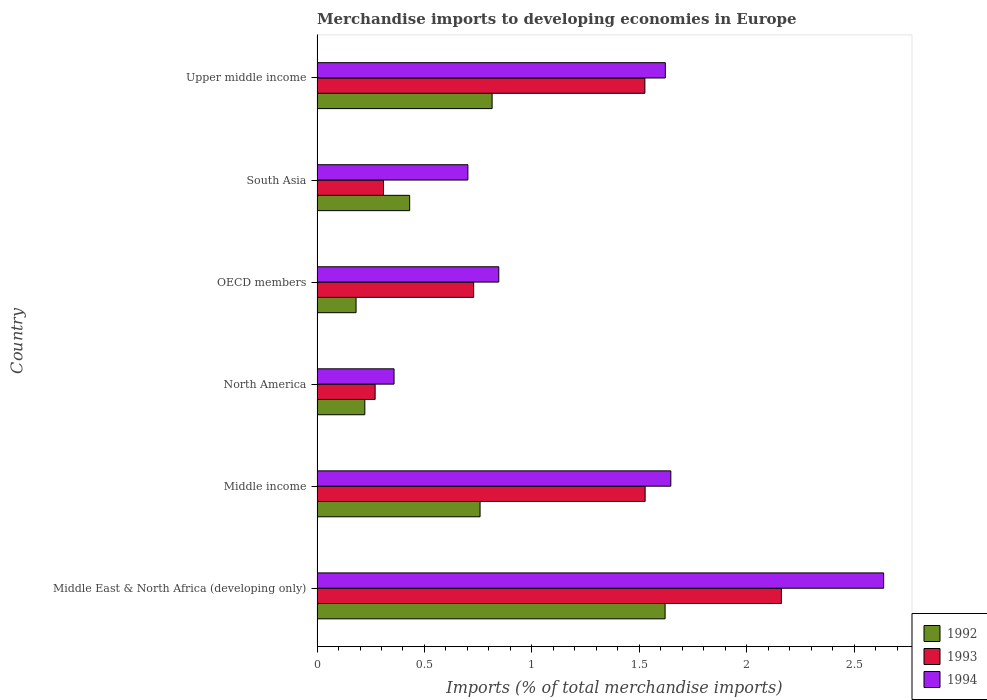How many different coloured bars are there?
Your answer should be compact. 3. How many groups of bars are there?
Offer a very short reply. 6. Are the number of bars per tick equal to the number of legend labels?
Keep it short and to the point. Yes. Are the number of bars on each tick of the Y-axis equal?
Your response must be concise. Yes. How many bars are there on the 6th tick from the top?
Ensure brevity in your answer.  3. How many bars are there on the 5th tick from the bottom?
Your response must be concise. 3. What is the label of the 3rd group of bars from the top?
Provide a succinct answer. OECD members. What is the percentage total merchandise imports in 1992 in OECD members?
Offer a terse response. 0.18. Across all countries, what is the maximum percentage total merchandise imports in 1992?
Your response must be concise. 1.62. Across all countries, what is the minimum percentage total merchandise imports in 1993?
Your answer should be compact. 0.27. In which country was the percentage total merchandise imports in 1993 maximum?
Your answer should be very brief. Middle East & North Africa (developing only). In which country was the percentage total merchandise imports in 1993 minimum?
Give a very brief answer. North America. What is the total percentage total merchandise imports in 1992 in the graph?
Your response must be concise. 4.03. What is the difference between the percentage total merchandise imports in 1994 in Middle East & North Africa (developing only) and that in South Asia?
Ensure brevity in your answer.  1.94. What is the difference between the percentage total merchandise imports in 1994 in Middle East & North Africa (developing only) and the percentage total merchandise imports in 1993 in OECD members?
Make the answer very short. 1.91. What is the average percentage total merchandise imports in 1992 per country?
Provide a short and direct response. 0.67. What is the difference between the percentage total merchandise imports in 1994 and percentage total merchandise imports in 1993 in Middle income?
Ensure brevity in your answer.  0.12. What is the ratio of the percentage total merchandise imports in 1993 in Middle East & North Africa (developing only) to that in Middle income?
Your answer should be compact. 1.42. Is the difference between the percentage total merchandise imports in 1994 in Middle income and Upper middle income greater than the difference between the percentage total merchandise imports in 1993 in Middle income and Upper middle income?
Your answer should be compact. Yes. What is the difference between the highest and the second highest percentage total merchandise imports in 1994?
Provide a succinct answer. 0.99. What is the difference between the highest and the lowest percentage total merchandise imports in 1993?
Your answer should be compact. 1.89. In how many countries, is the percentage total merchandise imports in 1994 greater than the average percentage total merchandise imports in 1994 taken over all countries?
Offer a terse response. 3. Is the sum of the percentage total merchandise imports in 1992 in Middle East & North Africa (developing only) and OECD members greater than the maximum percentage total merchandise imports in 1994 across all countries?
Keep it short and to the point. No. What does the 2nd bar from the bottom in Middle East & North Africa (developing only) represents?
Provide a short and direct response. 1993. How many bars are there?
Ensure brevity in your answer.  18. Are all the bars in the graph horizontal?
Make the answer very short. Yes. What is the difference between two consecutive major ticks on the X-axis?
Your response must be concise. 0.5. How many legend labels are there?
Keep it short and to the point. 3. What is the title of the graph?
Offer a very short reply. Merchandise imports to developing economies in Europe. What is the label or title of the X-axis?
Your response must be concise. Imports (% of total merchandise imports). What is the label or title of the Y-axis?
Your answer should be very brief. Country. What is the Imports (% of total merchandise imports) in 1992 in Middle East & North Africa (developing only)?
Your answer should be compact. 1.62. What is the Imports (% of total merchandise imports) of 1993 in Middle East & North Africa (developing only)?
Ensure brevity in your answer.  2.16. What is the Imports (% of total merchandise imports) of 1994 in Middle East & North Africa (developing only)?
Your answer should be very brief. 2.64. What is the Imports (% of total merchandise imports) in 1992 in Middle income?
Offer a very short reply. 0.76. What is the Imports (% of total merchandise imports) in 1993 in Middle income?
Provide a succinct answer. 1.53. What is the Imports (% of total merchandise imports) of 1994 in Middle income?
Make the answer very short. 1.65. What is the Imports (% of total merchandise imports) in 1992 in North America?
Offer a very short reply. 0.22. What is the Imports (% of total merchandise imports) of 1993 in North America?
Your answer should be compact. 0.27. What is the Imports (% of total merchandise imports) of 1994 in North America?
Make the answer very short. 0.36. What is the Imports (% of total merchandise imports) of 1992 in OECD members?
Offer a terse response. 0.18. What is the Imports (% of total merchandise imports) of 1993 in OECD members?
Provide a short and direct response. 0.73. What is the Imports (% of total merchandise imports) of 1994 in OECD members?
Make the answer very short. 0.85. What is the Imports (% of total merchandise imports) of 1992 in South Asia?
Your response must be concise. 0.43. What is the Imports (% of total merchandise imports) of 1993 in South Asia?
Keep it short and to the point. 0.31. What is the Imports (% of total merchandise imports) in 1994 in South Asia?
Give a very brief answer. 0.7. What is the Imports (% of total merchandise imports) in 1992 in Upper middle income?
Ensure brevity in your answer.  0.81. What is the Imports (% of total merchandise imports) in 1993 in Upper middle income?
Provide a succinct answer. 1.53. What is the Imports (% of total merchandise imports) of 1994 in Upper middle income?
Ensure brevity in your answer.  1.62. Across all countries, what is the maximum Imports (% of total merchandise imports) in 1992?
Provide a succinct answer. 1.62. Across all countries, what is the maximum Imports (% of total merchandise imports) in 1993?
Your answer should be compact. 2.16. Across all countries, what is the maximum Imports (% of total merchandise imports) in 1994?
Keep it short and to the point. 2.64. Across all countries, what is the minimum Imports (% of total merchandise imports) in 1992?
Your response must be concise. 0.18. Across all countries, what is the minimum Imports (% of total merchandise imports) in 1993?
Your response must be concise. 0.27. Across all countries, what is the minimum Imports (% of total merchandise imports) of 1994?
Offer a very short reply. 0.36. What is the total Imports (% of total merchandise imports) of 1992 in the graph?
Keep it short and to the point. 4.03. What is the total Imports (% of total merchandise imports) in 1993 in the graph?
Your response must be concise. 6.52. What is the total Imports (% of total merchandise imports) in 1994 in the graph?
Give a very brief answer. 7.81. What is the difference between the Imports (% of total merchandise imports) of 1992 in Middle East & North Africa (developing only) and that in Middle income?
Provide a succinct answer. 0.86. What is the difference between the Imports (% of total merchandise imports) of 1993 in Middle East & North Africa (developing only) and that in Middle income?
Provide a succinct answer. 0.63. What is the difference between the Imports (% of total merchandise imports) of 1992 in Middle East & North Africa (developing only) and that in North America?
Provide a short and direct response. 1.4. What is the difference between the Imports (% of total merchandise imports) in 1993 in Middle East & North Africa (developing only) and that in North America?
Give a very brief answer. 1.89. What is the difference between the Imports (% of total merchandise imports) of 1994 in Middle East & North Africa (developing only) and that in North America?
Provide a succinct answer. 2.28. What is the difference between the Imports (% of total merchandise imports) of 1992 in Middle East & North Africa (developing only) and that in OECD members?
Keep it short and to the point. 1.44. What is the difference between the Imports (% of total merchandise imports) of 1993 in Middle East & North Africa (developing only) and that in OECD members?
Offer a terse response. 1.43. What is the difference between the Imports (% of total merchandise imports) in 1994 in Middle East & North Africa (developing only) and that in OECD members?
Keep it short and to the point. 1.79. What is the difference between the Imports (% of total merchandise imports) in 1992 in Middle East & North Africa (developing only) and that in South Asia?
Provide a succinct answer. 1.19. What is the difference between the Imports (% of total merchandise imports) of 1993 in Middle East & North Africa (developing only) and that in South Asia?
Offer a terse response. 1.85. What is the difference between the Imports (% of total merchandise imports) of 1994 in Middle East & North Africa (developing only) and that in South Asia?
Your answer should be compact. 1.94. What is the difference between the Imports (% of total merchandise imports) in 1992 in Middle East & North Africa (developing only) and that in Upper middle income?
Provide a short and direct response. 0.81. What is the difference between the Imports (% of total merchandise imports) in 1993 in Middle East & North Africa (developing only) and that in Upper middle income?
Make the answer very short. 0.64. What is the difference between the Imports (% of total merchandise imports) of 1994 in Middle East & North Africa (developing only) and that in Upper middle income?
Make the answer very short. 1.02. What is the difference between the Imports (% of total merchandise imports) in 1992 in Middle income and that in North America?
Ensure brevity in your answer.  0.54. What is the difference between the Imports (% of total merchandise imports) in 1993 in Middle income and that in North America?
Provide a short and direct response. 1.26. What is the difference between the Imports (% of total merchandise imports) in 1994 in Middle income and that in North America?
Keep it short and to the point. 1.29. What is the difference between the Imports (% of total merchandise imports) of 1992 in Middle income and that in OECD members?
Provide a succinct answer. 0.58. What is the difference between the Imports (% of total merchandise imports) in 1993 in Middle income and that in OECD members?
Ensure brevity in your answer.  0.8. What is the difference between the Imports (% of total merchandise imports) in 1994 in Middle income and that in OECD members?
Your response must be concise. 0.8. What is the difference between the Imports (% of total merchandise imports) in 1992 in Middle income and that in South Asia?
Your response must be concise. 0.33. What is the difference between the Imports (% of total merchandise imports) of 1993 in Middle income and that in South Asia?
Ensure brevity in your answer.  1.22. What is the difference between the Imports (% of total merchandise imports) of 1994 in Middle income and that in South Asia?
Your answer should be compact. 0.94. What is the difference between the Imports (% of total merchandise imports) of 1992 in Middle income and that in Upper middle income?
Provide a short and direct response. -0.06. What is the difference between the Imports (% of total merchandise imports) in 1993 in Middle income and that in Upper middle income?
Keep it short and to the point. 0. What is the difference between the Imports (% of total merchandise imports) in 1994 in Middle income and that in Upper middle income?
Offer a terse response. 0.03. What is the difference between the Imports (% of total merchandise imports) of 1992 in North America and that in OECD members?
Your response must be concise. 0.04. What is the difference between the Imports (% of total merchandise imports) in 1993 in North America and that in OECD members?
Offer a terse response. -0.46. What is the difference between the Imports (% of total merchandise imports) of 1994 in North America and that in OECD members?
Make the answer very short. -0.49. What is the difference between the Imports (% of total merchandise imports) in 1992 in North America and that in South Asia?
Your answer should be compact. -0.21. What is the difference between the Imports (% of total merchandise imports) of 1993 in North America and that in South Asia?
Give a very brief answer. -0.04. What is the difference between the Imports (% of total merchandise imports) in 1994 in North America and that in South Asia?
Make the answer very short. -0.34. What is the difference between the Imports (% of total merchandise imports) of 1992 in North America and that in Upper middle income?
Provide a succinct answer. -0.59. What is the difference between the Imports (% of total merchandise imports) in 1993 in North America and that in Upper middle income?
Offer a terse response. -1.26. What is the difference between the Imports (% of total merchandise imports) of 1994 in North America and that in Upper middle income?
Give a very brief answer. -1.26. What is the difference between the Imports (% of total merchandise imports) of 1992 in OECD members and that in South Asia?
Your response must be concise. -0.25. What is the difference between the Imports (% of total merchandise imports) of 1993 in OECD members and that in South Asia?
Your answer should be compact. 0.42. What is the difference between the Imports (% of total merchandise imports) of 1994 in OECD members and that in South Asia?
Your answer should be compact. 0.14. What is the difference between the Imports (% of total merchandise imports) in 1992 in OECD members and that in Upper middle income?
Your answer should be compact. -0.63. What is the difference between the Imports (% of total merchandise imports) in 1993 in OECD members and that in Upper middle income?
Your answer should be compact. -0.8. What is the difference between the Imports (% of total merchandise imports) of 1994 in OECD members and that in Upper middle income?
Your answer should be compact. -0.78. What is the difference between the Imports (% of total merchandise imports) in 1992 in South Asia and that in Upper middle income?
Provide a succinct answer. -0.38. What is the difference between the Imports (% of total merchandise imports) in 1993 in South Asia and that in Upper middle income?
Provide a short and direct response. -1.22. What is the difference between the Imports (% of total merchandise imports) in 1994 in South Asia and that in Upper middle income?
Ensure brevity in your answer.  -0.92. What is the difference between the Imports (% of total merchandise imports) in 1992 in Middle East & North Africa (developing only) and the Imports (% of total merchandise imports) in 1993 in Middle income?
Make the answer very short. 0.09. What is the difference between the Imports (% of total merchandise imports) in 1992 in Middle East & North Africa (developing only) and the Imports (% of total merchandise imports) in 1994 in Middle income?
Ensure brevity in your answer.  -0.03. What is the difference between the Imports (% of total merchandise imports) in 1993 in Middle East & North Africa (developing only) and the Imports (% of total merchandise imports) in 1994 in Middle income?
Provide a short and direct response. 0.51. What is the difference between the Imports (% of total merchandise imports) of 1992 in Middle East & North Africa (developing only) and the Imports (% of total merchandise imports) of 1993 in North America?
Offer a very short reply. 1.35. What is the difference between the Imports (% of total merchandise imports) in 1992 in Middle East & North Africa (developing only) and the Imports (% of total merchandise imports) in 1994 in North America?
Provide a succinct answer. 1.26. What is the difference between the Imports (% of total merchandise imports) in 1993 in Middle East & North Africa (developing only) and the Imports (% of total merchandise imports) in 1994 in North America?
Your response must be concise. 1.8. What is the difference between the Imports (% of total merchandise imports) of 1992 in Middle East & North Africa (developing only) and the Imports (% of total merchandise imports) of 1993 in OECD members?
Provide a succinct answer. 0.89. What is the difference between the Imports (% of total merchandise imports) in 1992 in Middle East & North Africa (developing only) and the Imports (% of total merchandise imports) in 1994 in OECD members?
Provide a short and direct response. 0.77. What is the difference between the Imports (% of total merchandise imports) in 1993 in Middle East & North Africa (developing only) and the Imports (% of total merchandise imports) in 1994 in OECD members?
Offer a very short reply. 1.32. What is the difference between the Imports (% of total merchandise imports) of 1992 in Middle East & North Africa (developing only) and the Imports (% of total merchandise imports) of 1993 in South Asia?
Ensure brevity in your answer.  1.31. What is the difference between the Imports (% of total merchandise imports) in 1992 in Middle East & North Africa (developing only) and the Imports (% of total merchandise imports) in 1994 in South Asia?
Keep it short and to the point. 0.92. What is the difference between the Imports (% of total merchandise imports) of 1993 in Middle East & North Africa (developing only) and the Imports (% of total merchandise imports) of 1994 in South Asia?
Ensure brevity in your answer.  1.46. What is the difference between the Imports (% of total merchandise imports) in 1992 in Middle East & North Africa (developing only) and the Imports (% of total merchandise imports) in 1993 in Upper middle income?
Your answer should be very brief. 0.09. What is the difference between the Imports (% of total merchandise imports) of 1992 in Middle East & North Africa (developing only) and the Imports (% of total merchandise imports) of 1994 in Upper middle income?
Ensure brevity in your answer.  -0. What is the difference between the Imports (% of total merchandise imports) in 1993 in Middle East & North Africa (developing only) and the Imports (% of total merchandise imports) in 1994 in Upper middle income?
Your answer should be compact. 0.54. What is the difference between the Imports (% of total merchandise imports) of 1992 in Middle income and the Imports (% of total merchandise imports) of 1993 in North America?
Ensure brevity in your answer.  0.49. What is the difference between the Imports (% of total merchandise imports) of 1992 in Middle income and the Imports (% of total merchandise imports) of 1994 in North America?
Offer a terse response. 0.4. What is the difference between the Imports (% of total merchandise imports) of 1993 in Middle income and the Imports (% of total merchandise imports) of 1994 in North America?
Provide a succinct answer. 1.17. What is the difference between the Imports (% of total merchandise imports) in 1992 in Middle income and the Imports (% of total merchandise imports) in 1993 in OECD members?
Your answer should be compact. 0.03. What is the difference between the Imports (% of total merchandise imports) in 1992 in Middle income and the Imports (% of total merchandise imports) in 1994 in OECD members?
Ensure brevity in your answer.  -0.09. What is the difference between the Imports (% of total merchandise imports) of 1993 in Middle income and the Imports (% of total merchandise imports) of 1994 in OECD members?
Your answer should be very brief. 0.68. What is the difference between the Imports (% of total merchandise imports) in 1992 in Middle income and the Imports (% of total merchandise imports) in 1993 in South Asia?
Your answer should be compact. 0.45. What is the difference between the Imports (% of total merchandise imports) in 1992 in Middle income and the Imports (% of total merchandise imports) in 1994 in South Asia?
Your answer should be compact. 0.06. What is the difference between the Imports (% of total merchandise imports) of 1993 in Middle income and the Imports (% of total merchandise imports) of 1994 in South Asia?
Make the answer very short. 0.82. What is the difference between the Imports (% of total merchandise imports) in 1992 in Middle income and the Imports (% of total merchandise imports) in 1993 in Upper middle income?
Offer a very short reply. -0.77. What is the difference between the Imports (% of total merchandise imports) of 1992 in Middle income and the Imports (% of total merchandise imports) of 1994 in Upper middle income?
Provide a succinct answer. -0.86. What is the difference between the Imports (% of total merchandise imports) of 1993 in Middle income and the Imports (% of total merchandise imports) of 1994 in Upper middle income?
Ensure brevity in your answer.  -0.09. What is the difference between the Imports (% of total merchandise imports) in 1992 in North America and the Imports (% of total merchandise imports) in 1993 in OECD members?
Your answer should be compact. -0.51. What is the difference between the Imports (% of total merchandise imports) of 1992 in North America and the Imports (% of total merchandise imports) of 1994 in OECD members?
Keep it short and to the point. -0.62. What is the difference between the Imports (% of total merchandise imports) in 1993 in North America and the Imports (% of total merchandise imports) in 1994 in OECD members?
Offer a terse response. -0.58. What is the difference between the Imports (% of total merchandise imports) in 1992 in North America and the Imports (% of total merchandise imports) in 1993 in South Asia?
Give a very brief answer. -0.09. What is the difference between the Imports (% of total merchandise imports) in 1992 in North America and the Imports (% of total merchandise imports) in 1994 in South Asia?
Provide a succinct answer. -0.48. What is the difference between the Imports (% of total merchandise imports) in 1993 in North America and the Imports (% of total merchandise imports) in 1994 in South Asia?
Provide a succinct answer. -0.43. What is the difference between the Imports (% of total merchandise imports) in 1992 in North America and the Imports (% of total merchandise imports) in 1993 in Upper middle income?
Keep it short and to the point. -1.3. What is the difference between the Imports (% of total merchandise imports) of 1992 in North America and the Imports (% of total merchandise imports) of 1994 in Upper middle income?
Offer a very short reply. -1.4. What is the difference between the Imports (% of total merchandise imports) of 1993 in North America and the Imports (% of total merchandise imports) of 1994 in Upper middle income?
Your answer should be compact. -1.35. What is the difference between the Imports (% of total merchandise imports) of 1992 in OECD members and the Imports (% of total merchandise imports) of 1993 in South Asia?
Your answer should be very brief. -0.13. What is the difference between the Imports (% of total merchandise imports) of 1992 in OECD members and the Imports (% of total merchandise imports) of 1994 in South Asia?
Provide a short and direct response. -0.52. What is the difference between the Imports (% of total merchandise imports) in 1993 in OECD members and the Imports (% of total merchandise imports) in 1994 in South Asia?
Provide a succinct answer. 0.03. What is the difference between the Imports (% of total merchandise imports) of 1992 in OECD members and the Imports (% of total merchandise imports) of 1993 in Upper middle income?
Your answer should be very brief. -1.34. What is the difference between the Imports (% of total merchandise imports) in 1992 in OECD members and the Imports (% of total merchandise imports) in 1994 in Upper middle income?
Provide a short and direct response. -1.44. What is the difference between the Imports (% of total merchandise imports) of 1993 in OECD members and the Imports (% of total merchandise imports) of 1994 in Upper middle income?
Your answer should be compact. -0.89. What is the difference between the Imports (% of total merchandise imports) of 1992 in South Asia and the Imports (% of total merchandise imports) of 1993 in Upper middle income?
Your answer should be very brief. -1.09. What is the difference between the Imports (% of total merchandise imports) in 1992 in South Asia and the Imports (% of total merchandise imports) in 1994 in Upper middle income?
Ensure brevity in your answer.  -1.19. What is the difference between the Imports (% of total merchandise imports) of 1993 in South Asia and the Imports (% of total merchandise imports) of 1994 in Upper middle income?
Ensure brevity in your answer.  -1.31. What is the average Imports (% of total merchandise imports) in 1992 per country?
Your answer should be compact. 0.67. What is the average Imports (% of total merchandise imports) in 1993 per country?
Ensure brevity in your answer.  1.09. What is the average Imports (% of total merchandise imports) in 1994 per country?
Your answer should be very brief. 1.3. What is the difference between the Imports (% of total merchandise imports) of 1992 and Imports (% of total merchandise imports) of 1993 in Middle East & North Africa (developing only)?
Offer a terse response. -0.54. What is the difference between the Imports (% of total merchandise imports) in 1992 and Imports (% of total merchandise imports) in 1994 in Middle East & North Africa (developing only)?
Keep it short and to the point. -1.02. What is the difference between the Imports (% of total merchandise imports) of 1993 and Imports (% of total merchandise imports) of 1994 in Middle East & North Africa (developing only)?
Your answer should be very brief. -0.48. What is the difference between the Imports (% of total merchandise imports) in 1992 and Imports (% of total merchandise imports) in 1993 in Middle income?
Provide a succinct answer. -0.77. What is the difference between the Imports (% of total merchandise imports) of 1992 and Imports (% of total merchandise imports) of 1994 in Middle income?
Provide a short and direct response. -0.89. What is the difference between the Imports (% of total merchandise imports) in 1993 and Imports (% of total merchandise imports) in 1994 in Middle income?
Provide a short and direct response. -0.12. What is the difference between the Imports (% of total merchandise imports) in 1992 and Imports (% of total merchandise imports) in 1993 in North America?
Your response must be concise. -0.05. What is the difference between the Imports (% of total merchandise imports) in 1992 and Imports (% of total merchandise imports) in 1994 in North America?
Provide a succinct answer. -0.14. What is the difference between the Imports (% of total merchandise imports) in 1993 and Imports (% of total merchandise imports) in 1994 in North America?
Keep it short and to the point. -0.09. What is the difference between the Imports (% of total merchandise imports) of 1992 and Imports (% of total merchandise imports) of 1993 in OECD members?
Make the answer very short. -0.55. What is the difference between the Imports (% of total merchandise imports) in 1992 and Imports (% of total merchandise imports) in 1994 in OECD members?
Ensure brevity in your answer.  -0.66. What is the difference between the Imports (% of total merchandise imports) in 1993 and Imports (% of total merchandise imports) in 1994 in OECD members?
Your answer should be very brief. -0.12. What is the difference between the Imports (% of total merchandise imports) in 1992 and Imports (% of total merchandise imports) in 1993 in South Asia?
Your response must be concise. 0.12. What is the difference between the Imports (% of total merchandise imports) of 1992 and Imports (% of total merchandise imports) of 1994 in South Asia?
Ensure brevity in your answer.  -0.27. What is the difference between the Imports (% of total merchandise imports) in 1993 and Imports (% of total merchandise imports) in 1994 in South Asia?
Make the answer very short. -0.39. What is the difference between the Imports (% of total merchandise imports) of 1992 and Imports (% of total merchandise imports) of 1993 in Upper middle income?
Your answer should be very brief. -0.71. What is the difference between the Imports (% of total merchandise imports) in 1992 and Imports (% of total merchandise imports) in 1994 in Upper middle income?
Provide a succinct answer. -0.81. What is the difference between the Imports (% of total merchandise imports) of 1993 and Imports (% of total merchandise imports) of 1994 in Upper middle income?
Ensure brevity in your answer.  -0.1. What is the ratio of the Imports (% of total merchandise imports) in 1992 in Middle East & North Africa (developing only) to that in Middle income?
Ensure brevity in your answer.  2.14. What is the ratio of the Imports (% of total merchandise imports) in 1993 in Middle East & North Africa (developing only) to that in Middle income?
Your answer should be very brief. 1.42. What is the ratio of the Imports (% of total merchandise imports) of 1994 in Middle East & North Africa (developing only) to that in Middle income?
Your answer should be very brief. 1.6. What is the ratio of the Imports (% of total merchandise imports) in 1992 in Middle East & North Africa (developing only) to that in North America?
Keep it short and to the point. 7.28. What is the ratio of the Imports (% of total merchandise imports) of 1993 in Middle East & North Africa (developing only) to that in North America?
Your response must be concise. 8. What is the ratio of the Imports (% of total merchandise imports) in 1994 in Middle East & North Africa (developing only) to that in North America?
Offer a very short reply. 7.36. What is the ratio of the Imports (% of total merchandise imports) in 1992 in Middle East & North Africa (developing only) to that in OECD members?
Keep it short and to the point. 8.92. What is the ratio of the Imports (% of total merchandise imports) in 1993 in Middle East & North Africa (developing only) to that in OECD members?
Keep it short and to the point. 2.97. What is the ratio of the Imports (% of total merchandise imports) in 1994 in Middle East & North Africa (developing only) to that in OECD members?
Make the answer very short. 3.12. What is the ratio of the Imports (% of total merchandise imports) of 1992 in Middle East & North Africa (developing only) to that in South Asia?
Your response must be concise. 3.76. What is the ratio of the Imports (% of total merchandise imports) of 1993 in Middle East & North Africa (developing only) to that in South Asia?
Provide a succinct answer. 6.99. What is the ratio of the Imports (% of total merchandise imports) of 1994 in Middle East & North Africa (developing only) to that in South Asia?
Your answer should be compact. 3.76. What is the ratio of the Imports (% of total merchandise imports) in 1992 in Middle East & North Africa (developing only) to that in Upper middle income?
Give a very brief answer. 1.99. What is the ratio of the Imports (% of total merchandise imports) in 1993 in Middle East & North Africa (developing only) to that in Upper middle income?
Give a very brief answer. 1.42. What is the ratio of the Imports (% of total merchandise imports) in 1994 in Middle East & North Africa (developing only) to that in Upper middle income?
Keep it short and to the point. 1.63. What is the ratio of the Imports (% of total merchandise imports) of 1992 in Middle income to that in North America?
Offer a very short reply. 3.41. What is the ratio of the Imports (% of total merchandise imports) of 1993 in Middle income to that in North America?
Offer a terse response. 5.65. What is the ratio of the Imports (% of total merchandise imports) in 1994 in Middle income to that in North America?
Your response must be concise. 4.6. What is the ratio of the Imports (% of total merchandise imports) in 1992 in Middle income to that in OECD members?
Your answer should be very brief. 4.18. What is the ratio of the Imports (% of total merchandise imports) in 1993 in Middle income to that in OECD members?
Your answer should be compact. 2.1. What is the ratio of the Imports (% of total merchandise imports) in 1994 in Middle income to that in OECD members?
Ensure brevity in your answer.  1.95. What is the ratio of the Imports (% of total merchandise imports) in 1992 in Middle income to that in South Asia?
Your answer should be compact. 1.76. What is the ratio of the Imports (% of total merchandise imports) of 1993 in Middle income to that in South Asia?
Provide a succinct answer. 4.94. What is the ratio of the Imports (% of total merchandise imports) in 1994 in Middle income to that in South Asia?
Give a very brief answer. 2.35. What is the ratio of the Imports (% of total merchandise imports) of 1992 in Middle income to that in Upper middle income?
Provide a short and direct response. 0.93. What is the ratio of the Imports (% of total merchandise imports) in 1993 in Middle income to that in Upper middle income?
Make the answer very short. 1. What is the ratio of the Imports (% of total merchandise imports) in 1994 in Middle income to that in Upper middle income?
Give a very brief answer. 1.02. What is the ratio of the Imports (% of total merchandise imports) of 1992 in North America to that in OECD members?
Provide a succinct answer. 1.23. What is the ratio of the Imports (% of total merchandise imports) in 1993 in North America to that in OECD members?
Provide a short and direct response. 0.37. What is the ratio of the Imports (% of total merchandise imports) of 1994 in North America to that in OECD members?
Your response must be concise. 0.42. What is the ratio of the Imports (% of total merchandise imports) of 1992 in North America to that in South Asia?
Keep it short and to the point. 0.52. What is the ratio of the Imports (% of total merchandise imports) of 1993 in North America to that in South Asia?
Offer a terse response. 0.87. What is the ratio of the Imports (% of total merchandise imports) in 1994 in North America to that in South Asia?
Offer a very short reply. 0.51. What is the ratio of the Imports (% of total merchandise imports) in 1992 in North America to that in Upper middle income?
Give a very brief answer. 0.27. What is the ratio of the Imports (% of total merchandise imports) in 1993 in North America to that in Upper middle income?
Ensure brevity in your answer.  0.18. What is the ratio of the Imports (% of total merchandise imports) in 1994 in North America to that in Upper middle income?
Make the answer very short. 0.22. What is the ratio of the Imports (% of total merchandise imports) in 1992 in OECD members to that in South Asia?
Your answer should be compact. 0.42. What is the ratio of the Imports (% of total merchandise imports) of 1993 in OECD members to that in South Asia?
Keep it short and to the point. 2.36. What is the ratio of the Imports (% of total merchandise imports) in 1994 in OECD members to that in South Asia?
Offer a very short reply. 1.2. What is the ratio of the Imports (% of total merchandise imports) of 1992 in OECD members to that in Upper middle income?
Make the answer very short. 0.22. What is the ratio of the Imports (% of total merchandise imports) in 1993 in OECD members to that in Upper middle income?
Provide a short and direct response. 0.48. What is the ratio of the Imports (% of total merchandise imports) of 1994 in OECD members to that in Upper middle income?
Provide a short and direct response. 0.52. What is the ratio of the Imports (% of total merchandise imports) of 1992 in South Asia to that in Upper middle income?
Your answer should be compact. 0.53. What is the ratio of the Imports (% of total merchandise imports) of 1993 in South Asia to that in Upper middle income?
Provide a succinct answer. 0.2. What is the ratio of the Imports (% of total merchandise imports) in 1994 in South Asia to that in Upper middle income?
Your answer should be very brief. 0.43. What is the difference between the highest and the second highest Imports (% of total merchandise imports) of 1992?
Give a very brief answer. 0.81. What is the difference between the highest and the second highest Imports (% of total merchandise imports) of 1993?
Give a very brief answer. 0.63. What is the difference between the highest and the lowest Imports (% of total merchandise imports) in 1992?
Give a very brief answer. 1.44. What is the difference between the highest and the lowest Imports (% of total merchandise imports) in 1993?
Provide a succinct answer. 1.89. What is the difference between the highest and the lowest Imports (% of total merchandise imports) of 1994?
Your response must be concise. 2.28. 